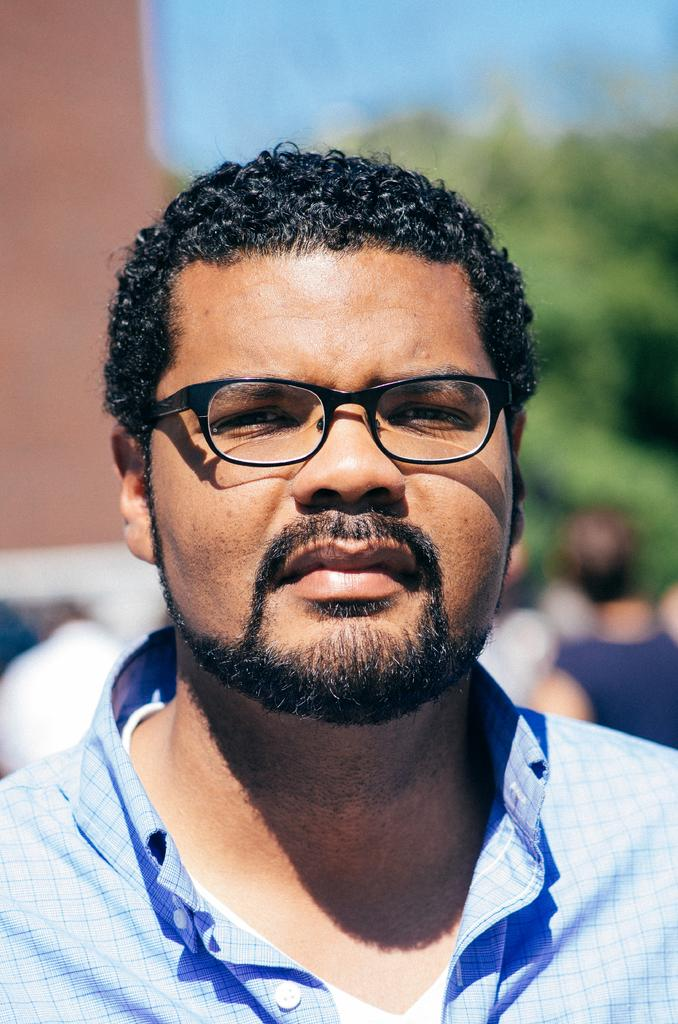What can be seen in the foreground of the image? A: There is a person with spectacles in the foreground of the image. What is visible in the background of the image? There are people and trees in the background of the image. What type of locket is the person wearing in the image? There is no locket visible in the image; the person is wearing spectacles. Can you tell me how many dolls are present in the image? There are no dolls present in the image. 